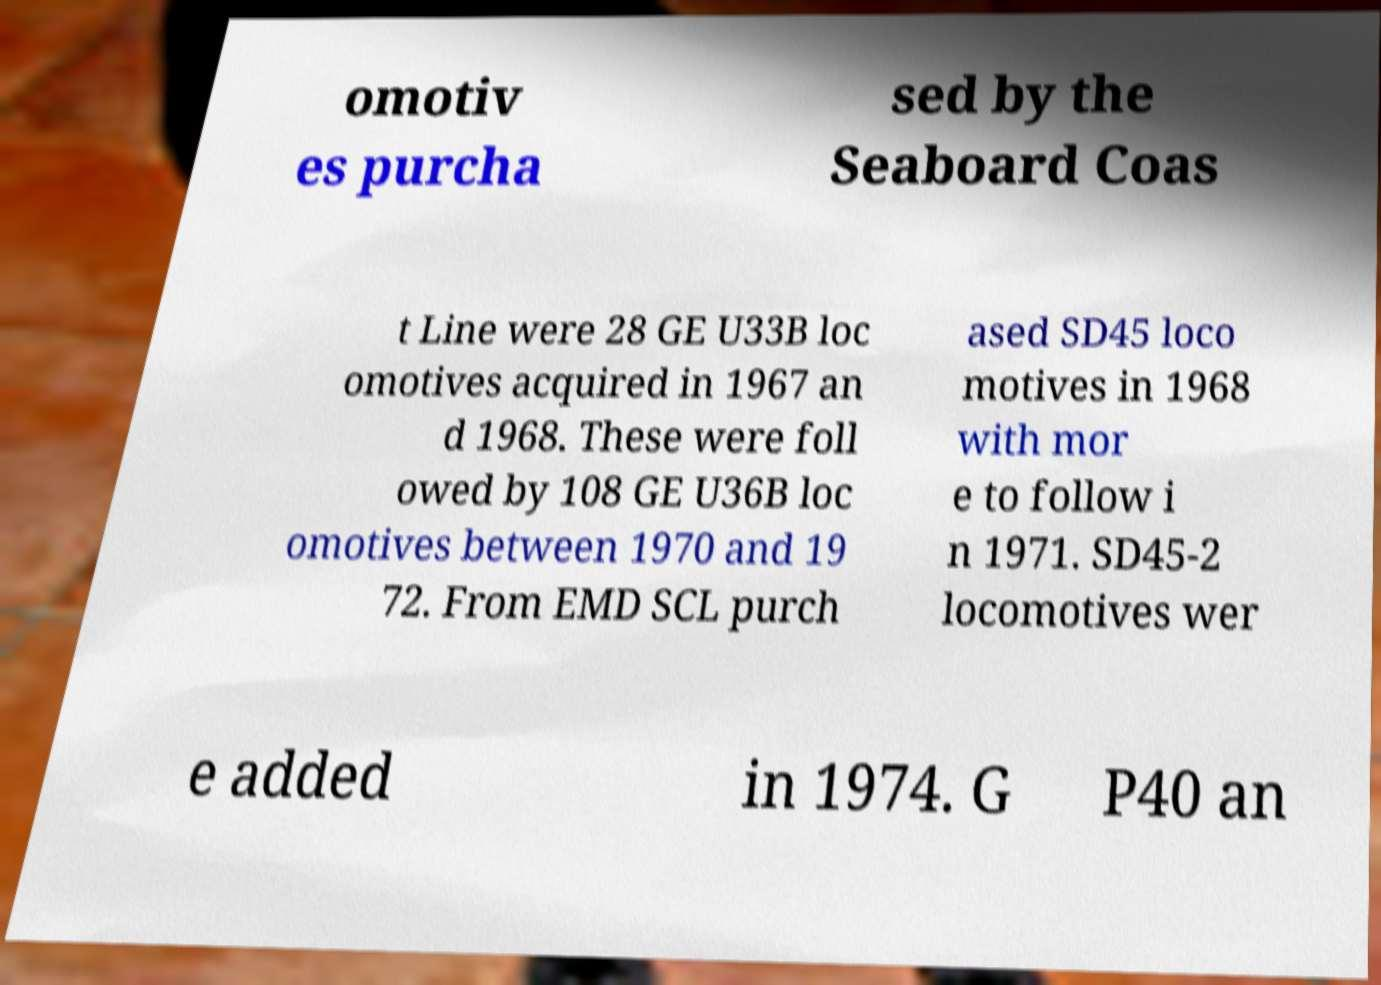Could you extract and type out the text from this image? omotiv es purcha sed by the Seaboard Coas t Line were 28 GE U33B loc omotives acquired in 1967 an d 1968. These were foll owed by 108 GE U36B loc omotives between 1970 and 19 72. From EMD SCL purch ased SD45 loco motives in 1968 with mor e to follow i n 1971. SD45-2 locomotives wer e added in 1974. G P40 an 